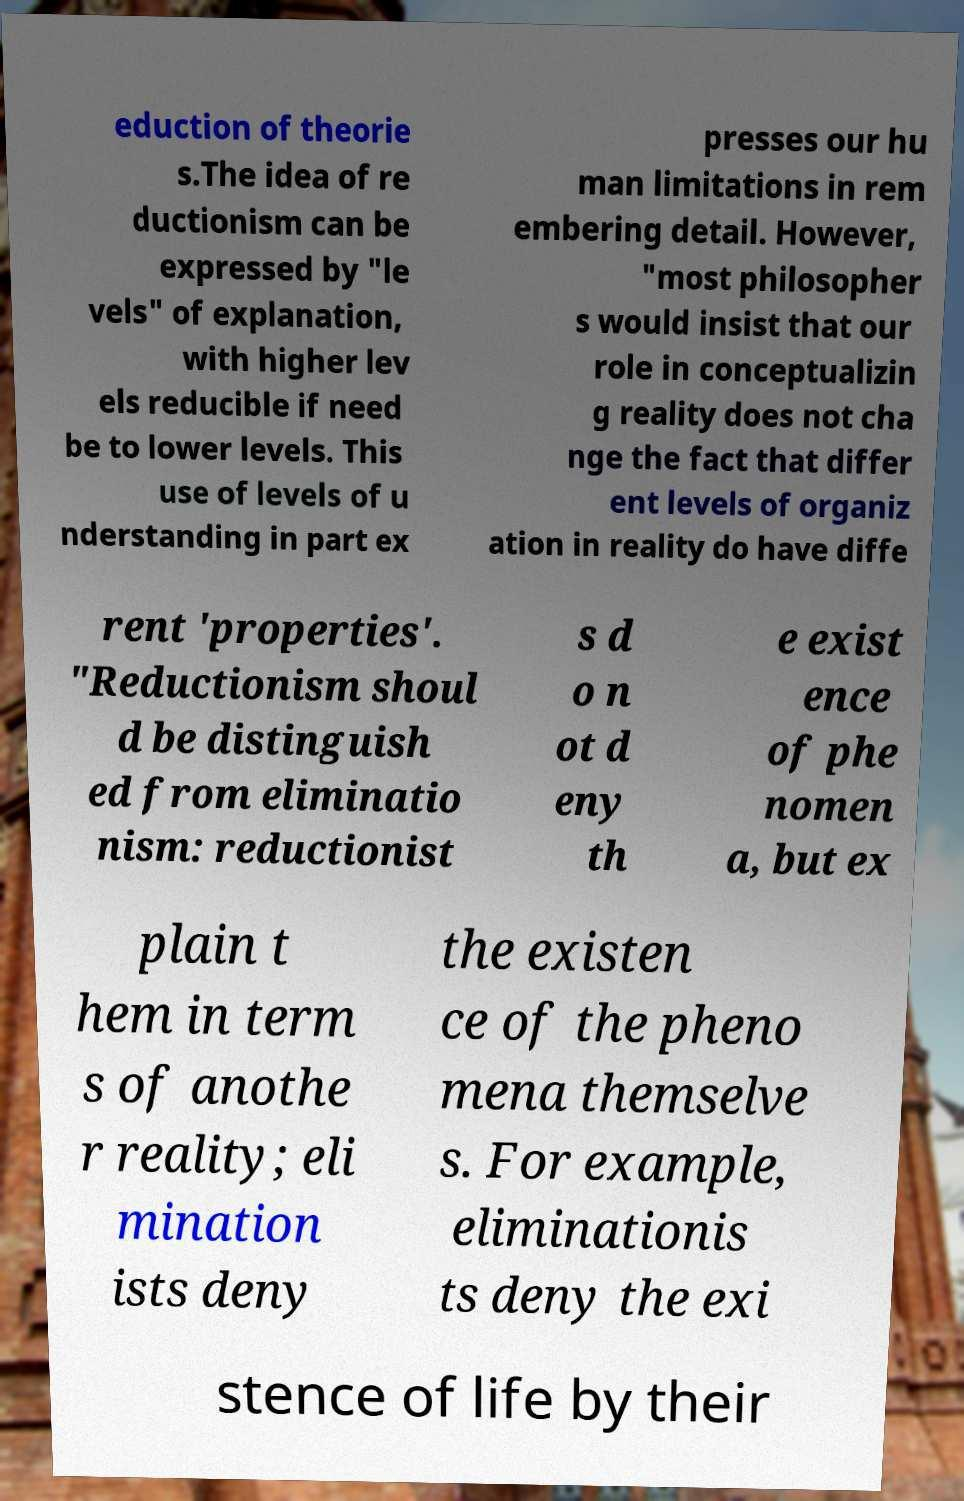I need the written content from this picture converted into text. Can you do that? eduction of theorie s.The idea of re ductionism can be expressed by "le vels" of explanation, with higher lev els reducible if need be to lower levels. This use of levels of u nderstanding in part ex presses our hu man limitations in rem embering detail. However, "most philosopher s would insist that our role in conceptualizin g reality does not cha nge the fact that differ ent levels of organiz ation in reality do have diffe rent 'properties'. "Reductionism shoul d be distinguish ed from eliminatio nism: reductionist s d o n ot d eny th e exist ence of phe nomen a, but ex plain t hem in term s of anothe r reality; eli mination ists deny the existen ce of the pheno mena themselve s. For example, eliminationis ts deny the exi stence of life by their 